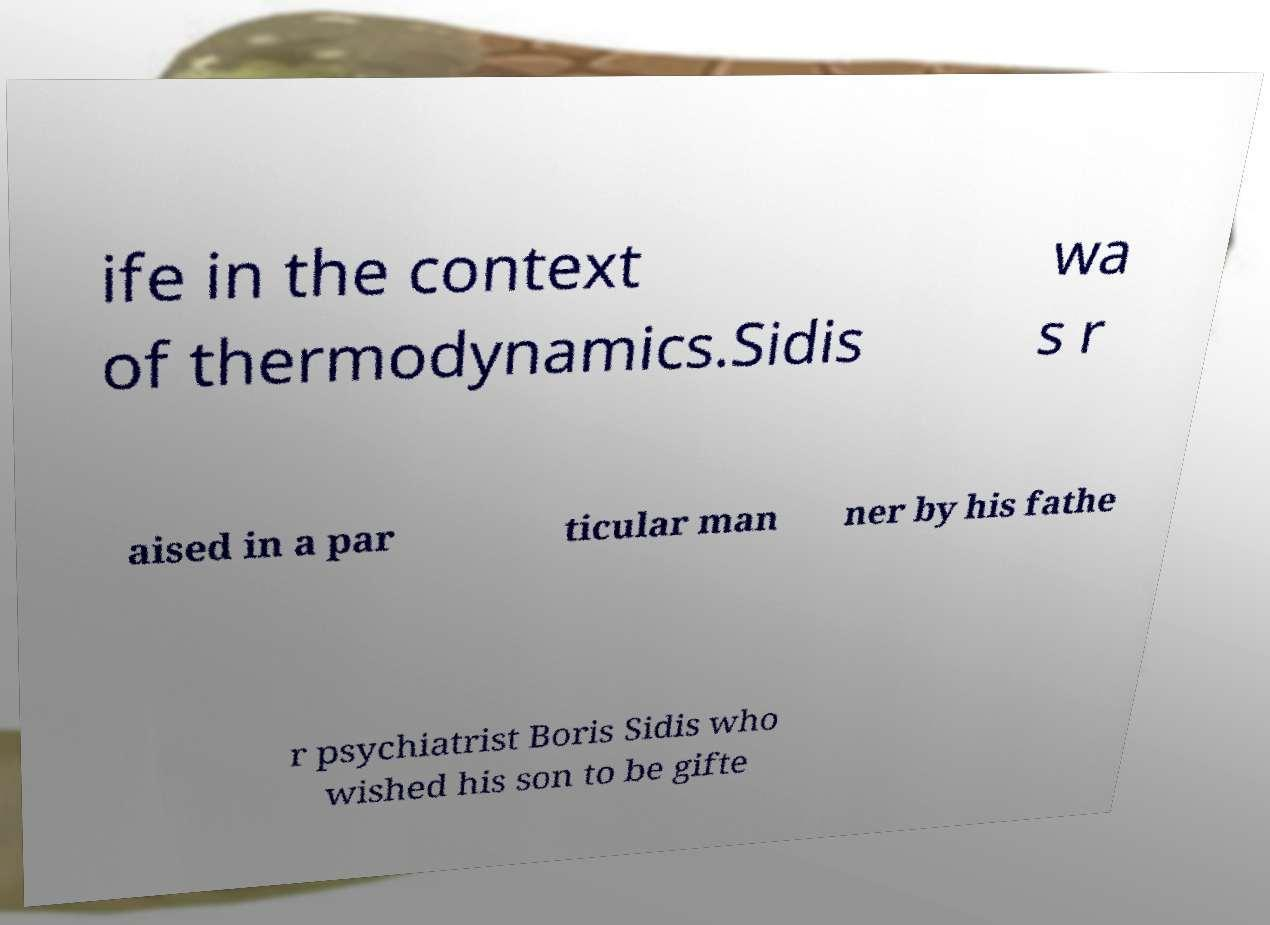Please identify and transcribe the text found in this image. ife in the context of thermodynamics.Sidis wa s r aised in a par ticular man ner by his fathe r psychiatrist Boris Sidis who wished his son to be gifte 